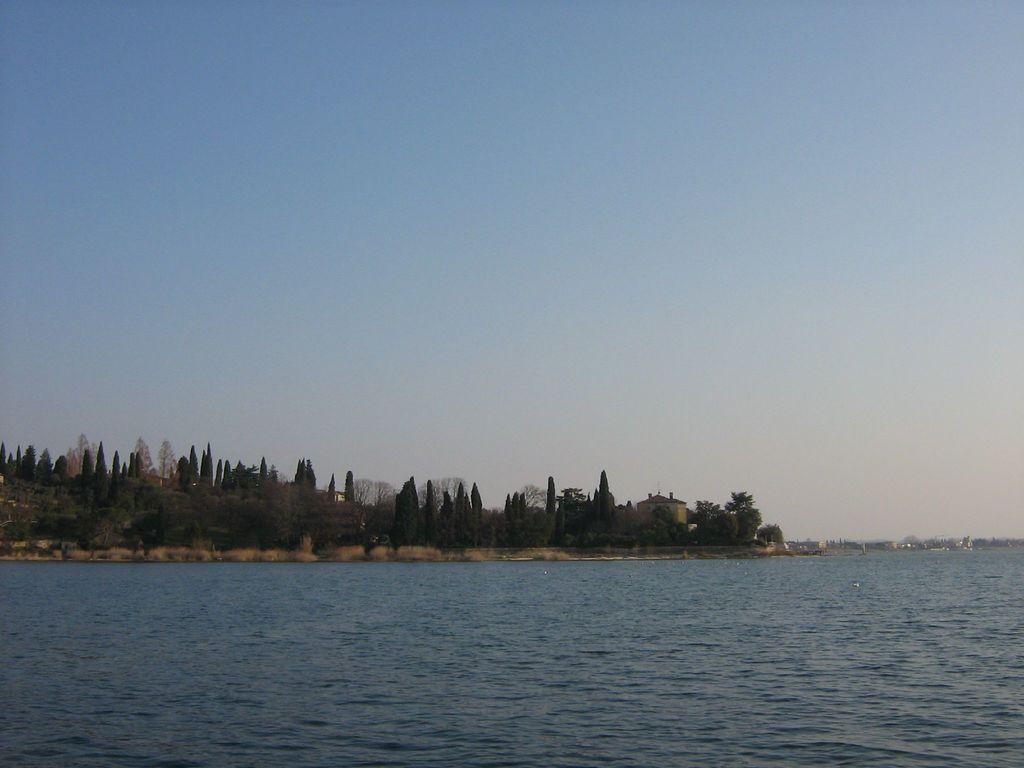Describe this image in one or two sentences. In this image we can see water, trees, buildings and the sky. 